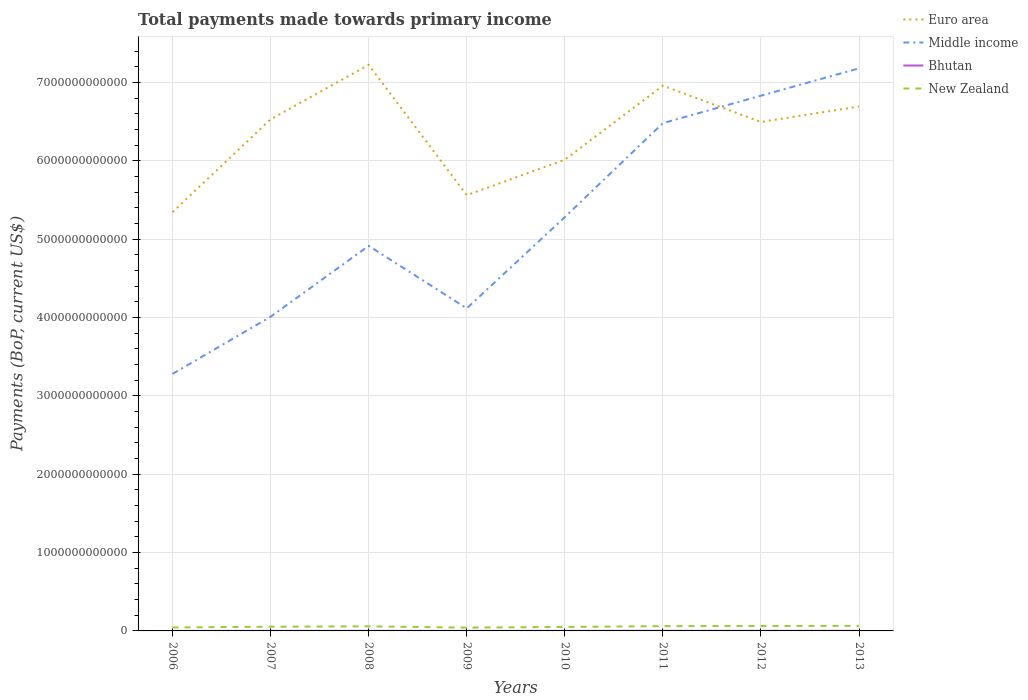Across all years, what is the maximum total payments made towards primary income in Bhutan?
Make the answer very short. 5.25e+08. In which year was the total payments made towards primary income in Bhutan maximum?
Offer a very short reply. 2006. What is the total total payments made towards primary income in Euro area in the graph?
Your answer should be very brief. -4.54e+11. What is the difference between the highest and the second highest total payments made towards primary income in Middle income?
Offer a terse response. 3.90e+12. Is the total payments made towards primary income in Euro area strictly greater than the total payments made towards primary income in New Zealand over the years?
Your response must be concise. No. How many lines are there?
Your answer should be very brief. 4. What is the difference between two consecutive major ticks on the Y-axis?
Give a very brief answer. 1.00e+12. Are the values on the major ticks of Y-axis written in scientific E-notation?
Offer a very short reply. No. Does the graph contain any zero values?
Provide a succinct answer. No. How are the legend labels stacked?
Keep it short and to the point. Vertical. What is the title of the graph?
Your answer should be compact. Total payments made towards primary income. Does "Turks and Caicos Islands" appear as one of the legend labels in the graph?
Ensure brevity in your answer.  No. What is the label or title of the X-axis?
Your response must be concise. Years. What is the label or title of the Y-axis?
Offer a terse response. Payments (BoP, current US$). What is the Payments (BoP, current US$) in Euro area in 2006?
Your answer should be very brief. 5.35e+12. What is the Payments (BoP, current US$) in Middle income in 2006?
Your response must be concise. 3.28e+12. What is the Payments (BoP, current US$) in Bhutan in 2006?
Give a very brief answer. 5.25e+08. What is the Payments (BoP, current US$) of New Zealand in 2006?
Provide a short and direct response. 4.44e+1. What is the Payments (BoP, current US$) in Euro area in 2007?
Make the answer very short. 6.53e+12. What is the Payments (BoP, current US$) in Middle income in 2007?
Offer a terse response. 4.01e+12. What is the Payments (BoP, current US$) in Bhutan in 2007?
Your answer should be very brief. 6.13e+08. What is the Payments (BoP, current US$) of New Zealand in 2007?
Offer a terse response. 5.38e+1. What is the Payments (BoP, current US$) in Euro area in 2008?
Provide a succinct answer. 7.23e+12. What is the Payments (BoP, current US$) of Middle income in 2008?
Offer a very short reply. 4.92e+12. What is the Payments (BoP, current US$) in Bhutan in 2008?
Provide a succinct answer. 8.35e+08. What is the Payments (BoP, current US$) of New Zealand in 2008?
Offer a very short reply. 5.83e+1. What is the Payments (BoP, current US$) in Euro area in 2009?
Keep it short and to the point. 5.56e+12. What is the Payments (BoP, current US$) in Middle income in 2009?
Offer a very short reply. 4.12e+12. What is the Payments (BoP, current US$) in Bhutan in 2009?
Ensure brevity in your answer.  7.35e+08. What is the Payments (BoP, current US$) of New Zealand in 2009?
Give a very brief answer. 4.20e+1. What is the Payments (BoP, current US$) in Euro area in 2010?
Ensure brevity in your answer.  6.02e+12. What is the Payments (BoP, current US$) of Middle income in 2010?
Give a very brief answer. 5.28e+12. What is the Payments (BoP, current US$) in Bhutan in 2010?
Your answer should be compact. 1.02e+09. What is the Payments (BoP, current US$) of New Zealand in 2010?
Ensure brevity in your answer.  5.09e+1. What is the Payments (BoP, current US$) of Euro area in 2011?
Your answer should be very brief. 6.96e+12. What is the Payments (BoP, current US$) in Middle income in 2011?
Your response must be concise. 6.48e+12. What is the Payments (BoP, current US$) of Bhutan in 2011?
Your response must be concise. 1.43e+09. What is the Payments (BoP, current US$) in New Zealand in 2011?
Provide a succinct answer. 6.09e+1. What is the Payments (BoP, current US$) of Euro area in 2012?
Your answer should be very brief. 6.50e+12. What is the Payments (BoP, current US$) of Middle income in 2012?
Give a very brief answer. 6.83e+12. What is the Payments (BoP, current US$) of Bhutan in 2012?
Your answer should be compact. 1.34e+09. What is the Payments (BoP, current US$) of New Zealand in 2012?
Offer a very short reply. 6.28e+1. What is the Payments (BoP, current US$) in Euro area in 2013?
Make the answer very short. 6.69e+12. What is the Payments (BoP, current US$) of Middle income in 2013?
Make the answer very short. 7.18e+12. What is the Payments (BoP, current US$) in Bhutan in 2013?
Make the answer very short. 1.32e+09. What is the Payments (BoP, current US$) of New Zealand in 2013?
Provide a short and direct response. 6.45e+1. Across all years, what is the maximum Payments (BoP, current US$) in Euro area?
Offer a very short reply. 7.23e+12. Across all years, what is the maximum Payments (BoP, current US$) of Middle income?
Offer a terse response. 7.18e+12. Across all years, what is the maximum Payments (BoP, current US$) in Bhutan?
Offer a terse response. 1.43e+09. Across all years, what is the maximum Payments (BoP, current US$) of New Zealand?
Your response must be concise. 6.45e+1. Across all years, what is the minimum Payments (BoP, current US$) in Euro area?
Provide a short and direct response. 5.35e+12. Across all years, what is the minimum Payments (BoP, current US$) of Middle income?
Give a very brief answer. 3.28e+12. Across all years, what is the minimum Payments (BoP, current US$) of Bhutan?
Your response must be concise. 5.25e+08. Across all years, what is the minimum Payments (BoP, current US$) in New Zealand?
Your response must be concise. 4.20e+1. What is the total Payments (BoP, current US$) of Euro area in the graph?
Provide a short and direct response. 5.08e+13. What is the total Payments (BoP, current US$) in Middle income in the graph?
Your answer should be compact. 4.21e+13. What is the total Payments (BoP, current US$) in Bhutan in the graph?
Your response must be concise. 7.82e+09. What is the total Payments (BoP, current US$) of New Zealand in the graph?
Your answer should be compact. 4.38e+11. What is the difference between the Payments (BoP, current US$) of Euro area in 2006 and that in 2007?
Make the answer very short. -1.19e+12. What is the difference between the Payments (BoP, current US$) in Middle income in 2006 and that in 2007?
Give a very brief answer. -7.29e+11. What is the difference between the Payments (BoP, current US$) of Bhutan in 2006 and that in 2007?
Provide a succinct answer. -8.84e+07. What is the difference between the Payments (BoP, current US$) of New Zealand in 2006 and that in 2007?
Your answer should be compact. -9.38e+09. What is the difference between the Payments (BoP, current US$) in Euro area in 2006 and that in 2008?
Provide a succinct answer. -1.88e+12. What is the difference between the Payments (BoP, current US$) in Middle income in 2006 and that in 2008?
Offer a terse response. -1.63e+12. What is the difference between the Payments (BoP, current US$) of Bhutan in 2006 and that in 2008?
Ensure brevity in your answer.  -3.11e+08. What is the difference between the Payments (BoP, current US$) of New Zealand in 2006 and that in 2008?
Provide a succinct answer. -1.39e+1. What is the difference between the Payments (BoP, current US$) in Euro area in 2006 and that in 2009?
Give a very brief answer. -2.16e+11. What is the difference between the Payments (BoP, current US$) of Middle income in 2006 and that in 2009?
Your answer should be compact. -8.36e+11. What is the difference between the Payments (BoP, current US$) of Bhutan in 2006 and that in 2009?
Your answer should be very brief. -2.10e+08. What is the difference between the Payments (BoP, current US$) of New Zealand in 2006 and that in 2009?
Provide a succinct answer. 2.41e+09. What is the difference between the Payments (BoP, current US$) in Euro area in 2006 and that in 2010?
Give a very brief answer. -6.69e+11. What is the difference between the Payments (BoP, current US$) in Middle income in 2006 and that in 2010?
Provide a succinct answer. -2.00e+12. What is the difference between the Payments (BoP, current US$) of Bhutan in 2006 and that in 2010?
Your answer should be compact. -4.99e+08. What is the difference between the Payments (BoP, current US$) of New Zealand in 2006 and that in 2010?
Offer a very short reply. -6.54e+09. What is the difference between the Payments (BoP, current US$) in Euro area in 2006 and that in 2011?
Make the answer very short. -1.61e+12. What is the difference between the Payments (BoP, current US$) of Middle income in 2006 and that in 2011?
Give a very brief answer. -3.20e+12. What is the difference between the Payments (BoP, current US$) of Bhutan in 2006 and that in 2011?
Ensure brevity in your answer.  -9.01e+08. What is the difference between the Payments (BoP, current US$) of New Zealand in 2006 and that in 2011?
Offer a very short reply. -1.65e+1. What is the difference between the Payments (BoP, current US$) of Euro area in 2006 and that in 2012?
Keep it short and to the point. -1.15e+12. What is the difference between the Payments (BoP, current US$) of Middle income in 2006 and that in 2012?
Give a very brief answer. -3.55e+12. What is the difference between the Payments (BoP, current US$) in Bhutan in 2006 and that in 2012?
Provide a succinct answer. -8.19e+08. What is the difference between the Payments (BoP, current US$) in New Zealand in 2006 and that in 2012?
Offer a very short reply. -1.84e+1. What is the difference between the Payments (BoP, current US$) in Euro area in 2006 and that in 2013?
Ensure brevity in your answer.  -1.35e+12. What is the difference between the Payments (BoP, current US$) in Middle income in 2006 and that in 2013?
Your answer should be compact. -3.90e+12. What is the difference between the Payments (BoP, current US$) in Bhutan in 2006 and that in 2013?
Your answer should be compact. -7.91e+08. What is the difference between the Payments (BoP, current US$) in New Zealand in 2006 and that in 2013?
Keep it short and to the point. -2.01e+1. What is the difference between the Payments (BoP, current US$) of Euro area in 2007 and that in 2008?
Your answer should be compact. -6.94e+11. What is the difference between the Payments (BoP, current US$) in Middle income in 2007 and that in 2008?
Offer a terse response. -9.05e+11. What is the difference between the Payments (BoP, current US$) of Bhutan in 2007 and that in 2008?
Your answer should be compact. -2.22e+08. What is the difference between the Payments (BoP, current US$) of New Zealand in 2007 and that in 2008?
Provide a succinct answer. -4.56e+09. What is the difference between the Payments (BoP, current US$) of Euro area in 2007 and that in 2009?
Give a very brief answer. 9.69e+11. What is the difference between the Payments (BoP, current US$) of Middle income in 2007 and that in 2009?
Offer a very short reply. -1.07e+11. What is the difference between the Payments (BoP, current US$) in Bhutan in 2007 and that in 2009?
Ensure brevity in your answer.  -1.22e+08. What is the difference between the Payments (BoP, current US$) in New Zealand in 2007 and that in 2009?
Your answer should be compact. 1.18e+1. What is the difference between the Payments (BoP, current US$) in Euro area in 2007 and that in 2010?
Offer a terse response. 5.16e+11. What is the difference between the Payments (BoP, current US$) in Middle income in 2007 and that in 2010?
Your response must be concise. -1.27e+12. What is the difference between the Payments (BoP, current US$) in Bhutan in 2007 and that in 2010?
Your response must be concise. -4.11e+08. What is the difference between the Payments (BoP, current US$) in New Zealand in 2007 and that in 2010?
Provide a succinct answer. 2.84e+09. What is the difference between the Payments (BoP, current US$) in Euro area in 2007 and that in 2011?
Make the answer very short. -4.29e+11. What is the difference between the Payments (BoP, current US$) in Middle income in 2007 and that in 2011?
Keep it short and to the point. -2.47e+12. What is the difference between the Payments (BoP, current US$) of Bhutan in 2007 and that in 2011?
Your response must be concise. -8.12e+08. What is the difference between the Payments (BoP, current US$) of New Zealand in 2007 and that in 2011?
Give a very brief answer. -7.08e+09. What is the difference between the Payments (BoP, current US$) in Euro area in 2007 and that in 2012?
Keep it short and to the point. 3.43e+1. What is the difference between the Payments (BoP, current US$) of Middle income in 2007 and that in 2012?
Ensure brevity in your answer.  -2.82e+12. What is the difference between the Payments (BoP, current US$) of Bhutan in 2007 and that in 2012?
Your answer should be compact. -7.30e+08. What is the difference between the Payments (BoP, current US$) in New Zealand in 2007 and that in 2012?
Offer a very short reply. -9.00e+09. What is the difference between the Payments (BoP, current US$) in Euro area in 2007 and that in 2013?
Make the answer very short. -1.63e+11. What is the difference between the Payments (BoP, current US$) of Middle income in 2007 and that in 2013?
Your response must be concise. -3.17e+12. What is the difference between the Payments (BoP, current US$) in Bhutan in 2007 and that in 2013?
Ensure brevity in your answer.  -7.03e+08. What is the difference between the Payments (BoP, current US$) in New Zealand in 2007 and that in 2013?
Your response must be concise. -1.08e+1. What is the difference between the Payments (BoP, current US$) in Euro area in 2008 and that in 2009?
Give a very brief answer. 1.66e+12. What is the difference between the Payments (BoP, current US$) in Middle income in 2008 and that in 2009?
Provide a succinct answer. 7.98e+11. What is the difference between the Payments (BoP, current US$) in Bhutan in 2008 and that in 2009?
Keep it short and to the point. 1.00e+08. What is the difference between the Payments (BoP, current US$) in New Zealand in 2008 and that in 2009?
Provide a succinct answer. 1.64e+1. What is the difference between the Payments (BoP, current US$) of Euro area in 2008 and that in 2010?
Ensure brevity in your answer.  1.21e+12. What is the difference between the Payments (BoP, current US$) in Middle income in 2008 and that in 2010?
Offer a terse response. -3.67e+11. What is the difference between the Payments (BoP, current US$) in Bhutan in 2008 and that in 2010?
Offer a very short reply. -1.88e+08. What is the difference between the Payments (BoP, current US$) in New Zealand in 2008 and that in 2010?
Make the answer very short. 7.40e+09. What is the difference between the Payments (BoP, current US$) of Euro area in 2008 and that in 2011?
Provide a succinct answer. 2.65e+11. What is the difference between the Payments (BoP, current US$) in Middle income in 2008 and that in 2011?
Give a very brief answer. -1.57e+12. What is the difference between the Payments (BoP, current US$) of Bhutan in 2008 and that in 2011?
Provide a short and direct response. -5.90e+08. What is the difference between the Payments (BoP, current US$) in New Zealand in 2008 and that in 2011?
Give a very brief answer. -2.52e+09. What is the difference between the Payments (BoP, current US$) in Euro area in 2008 and that in 2012?
Keep it short and to the point. 7.29e+11. What is the difference between the Payments (BoP, current US$) in Middle income in 2008 and that in 2012?
Give a very brief answer. -1.92e+12. What is the difference between the Payments (BoP, current US$) in Bhutan in 2008 and that in 2012?
Give a very brief answer. -5.08e+08. What is the difference between the Payments (BoP, current US$) of New Zealand in 2008 and that in 2012?
Provide a short and direct response. -4.45e+09. What is the difference between the Payments (BoP, current US$) of Euro area in 2008 and that in 2013?
Your response must be concise. 5.32e+11. What is the difference between the Payments (BoP, current US$) in Middle income in 2008 and that in 2013?
Ensure brevity in your answer.  -2.27e+12. What is the difference between the Payments (BoP, current US$) in Bhutan in 2008 and that in 2013?
Your response must be concise. -4.81e+08. What is the difference between the Payments (BoP, current US$) in New Zealand in 2008 and that in 2013?
Ensure brevity in your answer.  -6.20e+09. What is the difference between the Payments (BoP, current US$) of Euro area in 2009 and that in 2010?
Ensure brevity in your answer.  -4.54e+11. What is the difference between the Payments (BoP, current US$) in Middle income in 2009 and that in 2010?
Your answer should be compact. -1.16e+12. What is the difference between the Payments (BoP, current US$) of Bhutan in 2009 and that in 2010?
Your answer should be compact. -2.89e+08. What is the difference between the Payments (BoP, current US$) in New Zealand in 2009 and that in 2010?
Offer a very short reply. -8.95e+09. What is the difference between the Payments (BoP, current US$) in Euro area in 2009 and that in 2011?
Your response must be concise. -1.40e+12. What is the difference between the Payments (BoP, current US$) of Middle income in 2009 and that in 2011?
Provide a succinct answer. -2.36e+12. What is the difference between the Payments (BoP, current US$) of Bhutan in 2009 and that in 2011?
Make the answer very short. -6.90e+08. What is the difference between the Payments (BoP, current US$) in New Zealand in 2009 and that in 2011?
Offer a very short reply. -1.89e+1. What is the difference between the Payments (BoP, current US$) of Euro area in 2009 and that in 2012?
Provide a succinct answer. -9.35e+11. What is the difference between the Payments (BoP, current US$) in Middle income in 2009 and that in 2012?
Provide a short and direct response. -2.72e+12. What is the difference between the Payments (BoP, current US$) of Bhutan in 2009 and that in 2012?
Provide a short and direct response. -6.08e+08. What is the difference between the Payments (BoP, current US$) of New Zealand in 2009 and that in 2012?
Your answer should be compact. -2.08e+1. What is the difference between the Payments (BoP, current US$) of Euro area in 2009 and that in 2013?
Your response must be concise. -1.13e+12. What is the difference between the Payments (BoP, current US$) in Middle income in 2009 and that in 2013?
Your answer should be compact. -3.06e+12. What is the difference between the Payments (BoP, current US$) of Bhutan in 2009 and that in 2013?
Give a very brief answer. -5.81e+08. What is the difference between the Payments (BoP, current US$) of New Zealand in 2009 and that in 2013?
Your response must be concise. -2.25e+1. What is the difference between the Payments (BoP, current US$) in Euro area in 2010 and that in 2011?
Provide a short and direct response. -9.45e+11. What is the difference between the Payments (BoP, current US$) of Middle income in 2010 and that in 2011?
Your answer should be very brief. -1.20e+12. What is the difference between the Payments (BoP, current US$) in Bhutan in 2010 and that in 2011?
Offer a terse response. -4.02e+08. What is the difference between the Payments (BoP, current US$) of New Zealand in 2010 and that in 2011?
Your answer should be compact. -9.92e+09. What is the difference between the Payments (BoP, current US$) in Euro area in 2010 and that in 2012?
Make the answer very short. -4.82e+11. What is the difference between the Payments (BoP, current US$) in Middle income in 2010 and that in 2012?
Provide a succinct answer. -1.55e+12. What is the difference between the Payments (BoP, current US$) of Bhutan in 2010 and that in 2012?
Ensure brevity in your answer.  -3.20e+08. What is the difference between the Payments (BoP, current US$) in New Zealand in 2010 and that in 2012?
Offer a very short reply. -1.18e+1. What is the difference between the Payments (BoP, current US$) of Euro area in 2010 and that in 2013?
Offer a terse response. -6.79e+11. What is the difference between the Payments (BoP, current US$) in Middle income in 2010 and that in 2013?
Keep it short and to the point. -1.90e+12. What is the difference between the Payments (BoP, current US$) of Bhutan in 2010 and that in 2013?
Offer a very short reply. -2.92e+08. What is the difference between the Payments (BoP, current US$) in New Zealand in 2010 and that in 2013?
Provide a short and direct response. -1.36e+1. What is the difference between the Payments (BoP, current US$) in Euro area in 2011 and that in 2012?
Provide a succinct answer. 4.63e+11. What is the difference between the Payments (BoP, current US$) in Middle income in 2011 and that in 2012?
Provide a succinct answer. -3.51e+11. What is the difference between the Payments (BoP, current US$) in Bhutan in 2011 and that in 2012?
Ensure brevity in your answer.  8.20e+07. What is the difference between the Payments (BoP, current US$) in New Zealand in 2011 and that in 2012?
Provide a succinct answer. -1.92e+09. What is the difference between the Payments (BoP, current US$) in Euro area in 2011 and that in 2013?
Your response must be concise. 2.66e+11. What is the difference between the Payments (BoP, current US$) of Middle income in 2011 and that in 2013?
Your answer should be very brief. -7.00e+11. What is the difference between the Payments (BoP, current US$) in Bhutan in 2011 and that in 2013?
Give a very brief answer. 1.10e+08. What is the difference between the Payments (BoP, current US$) of New Zealand in 2011 and that in 2013?
Ensure brevity in your answer.  -3.68e+09. What is the difference between the Payments (BoP, current US$) of Euro area in 2012 and that in 2013?
Offer a very short reply. -1.97e+11. What is the difference between the Payments (BoP, current US$) in Middle income in 2012 and that in 2013?
Give a very brief answer. -3.49e+11. What is the difference between the Payments (BoP, current US$) in Bhutan in 2012 and that in 2013?
Provide a succinct answer. 2.76e+07. What is the difference between the Payments (BoP, current US$) of New Zealand in 2012 and that in 2013?
Make the answer very short. -1.75e+09. What is the difference between the Payments (BoP, current US$) in Euro area in 2006 and the Payments (BoP, current US$) in Middle income in 2007?
Offer a very short reply. 1.34e+12. What is the difference between the Payments (BoP, current US$) of Euro area in 2006 and the Payments (BoP, current US$) of Bhutan in 2007?
Your response must be concise. 5.35e+12. What is the difference between the Payments (BoP, current US$) of Euro area in 2006 and the Payments (BoP, current US$) of New Zealand in 2007?
Offer a very short reply. 5.29e+12. What is the difference between the Payments (BoP, current US$) of Middle income in 2006 and the Payments (BoP, current US$) of Bhutan in 2007?
Your answer should be very brief. 3.28e+12. What is the difference between the Payments (BoP, current US$) in Middle income in 2006 and the Payments (BoP, current US$) in New Zealand in 2007?
Your response must be concise. 3.23e+12. What is the difference between the Payments (BoP, current US$) in Bhutan in 2006 and the Payments (BoP, current US$) in New Zealand in 2007?
Ensure brevity in your answer.  -5.33e+1. What is the difference between the Payments (BoP, current US$) in Euro area in 2006 and the Payments (BoP, current US$) in Middle income in 2008?
Ensure brevity in your answer.  4.31e+11. What is the difference between the Payments (BoP, current US$) in Euro area in 2006 and the Payments (BoP, current US$) in Bhutan in 2008?
Your answer should be very brief. 5.35e+12. What is the difference between the Payments (BoP, current US$) in Euro area in 2006 and the Payments (BoP, current US$) in New Zealand in 2008?
Your answer should be very brief. 5.29e+12. What is the difference between the Payments (BoP, current US$) of Middle income in 2006 and the Payments (BoP, current US$) of Bhutan in 2008?
Offer a terse response. 3.28e+12. What is the difference between the Payments (BoP, current US$) of Middle income in 2006 and the Payments (BoP, current US$) of New Zealand in 2008?
Offer a terse response. 3.22e+12. What is the difference between the Payments (BoP, current US$) of Bhutan in 2006 and the Payments (BoP, current US$) of New Zealand in 2008?
Provide a succinct answer. -5.78e+1. What is the difference between the Payments (BoP, current US$) in Euro area in 2006 and the Payments (BoP, current US$) in Middle income in 2009?
Make the answer very short. 1.23e+12. What is the difference between the Payments (BoP, current US$) in Euro area in 2006 and the Payments (BoP, current US$) in Bhutan in 2009?
Provide a short and direct response. 5.35e+12. What is the difference between the Payments (BoP, current US$) of Euro area in 2006 and the Payments (BoP, current US$) of New Zealand in 2009?
Offer a terse response. 5.31e+12. What is the difference between the Payments (BoP, current US$) in Middle income in 2006 and the Payments (BoP, current US$) in Bhutan in 2009?
Offer a very short reply. 3.28e+12. What is the difference between the Payments (BoP, current US$) in Middle income in 2006 and the Payments (BoP, current US$) in New Zealand in 2009?
Ensure brevity in your answer.  3.24e+12. What is the difference between the Payments (BoP, current US$) in Bhutan in 2006 and the Payments (BoP, current US$) in New Zealand in 2009?
Offer a terse response. -4.15e+1. What is the difference between the Payments (BoP, current US$) in Euro area in 2006 and the Payments (BoP, current US$) in Middle income in 2010?
Provide a short and direct response. 6.41e+1. What is the difference between the Payments (BoP, current US$) of Euro area in 2006 and the Payments (BoP, current US$) of Bhutan in 2010?
Provide a succinct answer. 5.35e+12. What is the difference between the Payments (BoP, current US$) in Euro area in 2006 and the Payments (BoP, current US$) in New Zealand in 2010?
Your answer should be compact. 5.30e+12. What is the difference between the Payments (BoP, current US$) in Middle income in 2006 and the Payments (BoP, current US$) in Bhutan in 2010?
Your answer should be very brief. 3.28e+12. What is the difference between the Payments (BoP, current US$) in Middle income in 2006 and the Payments (BoP, current US$) in New Zealand in 2010?
Offer a terse response. 3.23e+12. What is the difference between the Payments (BoP, current US$) of Bhutan in 2006 and the Payments (BoP, current US$) of New Zealand in 2010?
Offer a terse response. -5.04e+1. What is the difference between the Payments (BoP, current US$) in Euro area in 2006 and the Payments (BoP, current US$) in Middle income in 2011?
Your answer should be very brief. -1.14e+12. What is the difference between the Payments (BoP, current US$) in Euro area in 2006 and the Payments (BoP, current US$) in Bhutan in 2011?
Your answer should be compact. 5.35e+12. What is the difference between the Payments (BoP, current US$) of Euro area in 2006 and the Payments (BoP, current US$) of New Zealand in 2011?
Make the answer very short. 5.29e+12. What is the difference between the Payments (BoP, current US$) in Middle income in 2006 and the Payments (BoP, current US$) in Bhutan in 2011?
Keep it short and to the point. 3.28e+12. What is the difference between the Payments (BoP, current US$) in Middle income in 2006 and the Payments (BoP, current US$) in New Zealand in 2011?
Make the answer very short. 3.22e+12. What is the difference between the Payments (BoP, current US$) in Bhutan in 2006 and the Payments (BoP, current US$) in New Zealand in 2011?
Your answer should be compact. -6.03e+1. What is the difference between the Payments (BoP, current US$) of Euro area in 2006 and the Payments (BoP, current US$) of Middle income in 2012?
Provide a succinct answer. -1.49e+12. What is the difference between the Payments (BoP, current US$) in Euro area in 2006 and the Payments (BoP, current US$) in Bhutan in 2012?
Your answer should be compact. 5.35e+12. What is the difference between the Payments (BoP, current US$) of Euro area in 2006 and the Payments (BoP, current US$) of New Zealand in 2012?
Keep it short and to the point. 5.28e+12. What is the difference between the Payments (BoP, current US$) in Middle income in 2006 and the Payments (BoP, current US$) in Bhutan in 2012?
Your response must be concise. 3.28e+12. What is the difference between the Payments (BoP, current US$) in Middle income in 2006 and the Payments (BoP, current US$) in New Zealand in 2012?
Ensure brevity in your answer.  3.22e+12. What is the difference between the Payments (BoP, current US$) of Bhutan in 2006 and the Payments (BoP, current US$) of New Zealand in 2012?
Your answer should be very brief. -6.23e+1. What is the difference between the Payments (BoP, current US$) in Euro area in 2006 and the Payments (BoP, current US$) in Middle income in 2013?
Provide a succinct answer. -1.84e+12. What is the difference between the Payments (BoP, current US$) in Euro area in 2006 and the Payments (BoP, current US$) in Bhutan in 2013?
Keep it short and to the point. 5.35e+12. What is the difference between the Payments (BoP, current US$) of Euro area in 2006 and the Payments (BoP, current US$) of New Zealand in 2013?
Your answer should be compact. 5.28e+12. What is the difference between the Payments (BoP, current US$) in Middle income in 2006 and the Payments (BoP, current US$) in Bhutan in 2013?
Make the answer very short. 3.28e+12. What is the difference between the Payments (BoP, current US$) in Middle income in 2006 and the Payments (BoP, current US$) in New Zealand in 2013?
Offer a terse response. 3.22e+12. What is the difference between the Payments (BoP, current US$) of Bhutan in 2006 and the Payments (BoP, current US$) of New Zealand in 2013?
Provide a succinct answer. -6.40e+1. What is the difference between the Payments (BoP, current US$) of Euro area in 2007 and the Payments (BoP, current US$) of Middle income in 2008?
Your answer should be compact. 1.62e+12. What is the difference between the Payments (BoP, current US$) of Euro area in 2007 and the Payments (BoP, current US$) of Bhutan in 2008?
Provide a succinct answer. 6.53e+12. What is the difference between the Payments (BoP, current US$) in Euro area in 2007 and the Payments (BoP, current US$) in New Zealand in 2008?
Offer a very short reply. 6.47e+12. What is the difference between the Payments (BoP, current US$) of Middle income in 2007 and the Payments (BoP, current US$) of Bhutan in 2008?
Offer a terse response. 4.01e+12. What is the difference between the Payments (BoP, current US$) of Middle income in 2007 and the Payments (BoP, current US$) of New Zealand in 2008?
Your response must be concise. 3.95e+12. What is the difference between the Payments (BoP, current US$) in Bhutan in 2007 and the Payments (BoP, current US$) in New Zealand in 2008?
Offer a terse response. -5.77e+1. What is the difference between the Payments (BoP, current US$) in Euro area in 2007 and the Payments (BoP, current US$) in Middle income in 2009?
Keep it short and to the point. 2.41e+12. What is the difference between the Payments (BoP, current US$) in Euro area in 2007 and the Payments (BoP, current US$) in Bhutan in 2009?
Give a very brief answer. 6.53e+12. What is the difference between the Payments (BoP, current US$) of Euro area in 2007 and the Payments (BoP, current US$) of New Zealand in 2009?
Offer a very short reply. 6.49e+12. What is the difference between the Payments (BoP, current US$) in Middle income in 2007 and the Payments (BoP, current US$) in Bhutan in 2009?
Offer a terse response. 4.01e+12. What is the difference between the Payments (BoP, current US$) of Middle income in 2007 and the Payments (BoP, current US$) of New Zealand in 2009?
Your answer should be very brief. 3.97e+12. What is the difference between the Payments (BoP, current US$) of Bhutan in 2007 and the Payments (BoP, current US$) of New Zealand in 2009?
Your answer should be compact. -4.14e+1. What is the difference between the Payments (BoP, current US$) in Euro area in 2007 and the Payments (BoP, current US$) in Middle income in 2010?
Keep it short and to the point. 1.25e+12. What is the difference between the Payments (BoP, current US$) of Euro area in 2007 and the Payments (BoP, current US$) of Bhutan in 2010?
Give a very brief answer. 6.53e+12. What is the difference between the Payments (BoP, current US$) in Euro area in 2007 and the Payments (BoP, current US$) in New Zealand in 2010?
Ensure brevity in your answer.  6.48e+12. What is the difference between the Payments (BoP, current US$) in Middle income in 2007 and the Payments (BoP, current US$) in Bhutan in 2010?
Provide a short and direct response. 4.01e+12. What is the difference between the Payments (BoP, current US$) in Middle income in 2007 and the Payments (BoP, current US$) in New Zealand in 2010?
Ensure brevity in your answer.  3.96e+12. What is the difference between the Payments (BoP, current US$) in Bhutan in 2007 and the Payments (BoP, current US$) in New Zealand in 2010?
Your answer should be very brief. -5.03e+1. What is the difference between the Payments (BoP, current US$) in Euro area in 2007 and the Payments (BoP, current US$) in Middle income in 2011?
Your answer should be compact. 4.93e+1. What is the difference between the Payments (BoP, current US$) of Euro area in 2007 and the Payments (BoP, current US$) of Bhutan in 2011?
Your answer should be compact. 6.53e+12. What is the difference between the Payments (BoP, current US$) of Euro area in 2007 and the Payments (BoP, current US$) of New Zealand in 2011?
Provide a short and direct response. 6.47e+12. What is the difference between the Payments (BoP, current US$) in Middle income in 2007 and the Payments (BoP, current US$) in Bhutan in 2011?
Give a very brief answer. 4.01e+12. What is the difference between the Payments (BoP, current US$) in Middle income in 2007 and the Payments (BoP, current US$) in New Zealand in 2011?
Give a very brief answer. 3.95e+12. What is the difference between the Payments (BoP, current US$) of Bhutan in 2007 and the Payments (BoP, current US$) of New Zealand in 2011?
Give a very brief answer. -6.03e+1. What is the difference between the Payments (BoP, current US$) of Euro area in 2007 and the Payments (BoP, current US$) of Middle income in 2012?
Your response must be concise. -3.01e+11. What is the difference between the Payments (BoP, current US$) in Euro area in 2007 and the Payments (BoP, current US$) in Bhutan in 2012?
Provide a short and direct response. 6.53e+12. What is the difference between the Payments (BoP, current US$) of Euro area in 2007 and the Payments (BoP, current US$) of New Zealand in 2012?
Provide a short and direct response. 6.47e+12. What is the difference between the Payments (BoP, current US$) in Middle income in 2007 and the Payments (BoP, current US$) in Bhutan in 2012?
Provide a succinct answer. 4.01e+12. What is the difference between the Payments (BoP, current US$) in Middle income in 2007 and the Payments (BoP, current US$) in New Zealand in 2012?
Offer a terse response. 3.95e+12. What is the difference between the Payments (BoP, current US$) of Bhutan in 2007 and the Payments (BoP, current US$) of New Zealand in 2012?
Give a very brief answer. -6.22e+1. What is the difference between the Payments (BoP, current US$) of Euro area in 2007 and the Payments (BoP, current US$) of Middle income in 2013?
Provide a succinct answer. -6.50e+11. What is the difference between the Payments (BoP, current US$) in Euro area in 2007 and the Payments (BoP, current US$) in Bhutan in 2013?
Keep it short and to the point. 6.53e+12. What is the difference between the Payments (BoP, current US$) of Euro area in 2007 and the Payments (BoP, current US$) of New Zealand in 2013?
Offer a very short reply. 6.47e+12. What is the difference between the Payments (BoP, current US$) in Middle income in 2007 and the Payments (BoP, current US$) in Bhutan in 2013?
Give a very brief answer. 4.01e+12. What is the difference between the Payments (BoP, current US$) in Middle income in 2007 and the Payments (BoP, current US$) in New Zealand in 2013?
Your response must be concise. 3.95e+12. What is the difference between the Payments (BoP, current US$) in Bhutan in 2007 and the Payments (BoP, current US$) in New Zealand in 2013?
Provide a short and direct response. -6.39e+1. What is the difference between the Payments (BoP, current US$) in Euro area in 2008 and the Payments (BoP, current US$) in Middle income in 2009?
Your answer should be compact. 3.11e+12. What is the difference between the Payments (BoP, current US$) in Euro area in 2008 and the Payments (BoP, current US$) in Bhutan in 2009?
Your answer should be very brief. 7.23e+12. What is the difference between the Payments (BoP, current US$) in Euro area in 2008 and the Payments (BoP, current US$) in New Zealand in 2009?
Your answer should be very brief. 7.18e+12. What is the difference between the Payments (BoP, current US$) of Middle income in 2008 and the Payments (BoP, current US$) of Bhutan in 2009?
Your answer should be very brief. 4.92e+12. What is the difference between the Payments (BoP, current US$) in Middle income in 2008 and the Payments (BoP, current US$) in New Zealand in 2009?
Give a very brief answer. 4.87e+12. What is the difference between the Payments (BoP, current US$) in Bhutan in 2008 and the Payments (BoP, current US$) in New Zealand in 2009?
Offer a terse response. -4.12e+1. What is the difference between the Payments (BoP, current US$) in Euro area in 2008 and the Payments (BoP, current US$) in Middle income in 2010?
Offer a terse response. 1.94e+12. What is the difference between the Payments (BoP, current US$) of Euro area in 2008 and the Payments (BoP, current US$) of Bhutan in 2010?
Give a very brief answer. 7.23e+12. What is the difference between the Payments (BoP, current US$) of Euro area in 2008 and the Payments (BoP, current US$) of New Zealand in 2010?
Provide a short and direct response. 7.18e+12. What is the difference between the Payments (BoP, current US$) in Middle income in 2008 and the Payments (BoP, current US$) in Bhutan in 2010?
Keep it short and to the point. 4.92e+12. What is the difference between the Payments (BoP, current US$) of Middle income in 2008 and the Payments (BoP, current US$) of New Zealand in 2010?
Provide a short and direct response. 4.87e+12. What is the difference between the Payments (BoP, current US$) in Bhutan in 2008 and the Payments (BoP, current US$) in New Zealand in 2010?
Provide a short and direct response. -5.01e+1. What is the difference between the Payments (BoP, current US$) in Euro area in 2008 and the Payments (BoP, current US$) in Middle income in 2011?
Provide a succinct answer. 7.44e+11. What is the difference between the Payments (BoP, current US$) of Euro area in 2008 and the Payments (BoP, current US$) of Bhutan in 2011?
Your answer should be compact. 7.23e+12. What is the difference between the Payments (BoP, current US$) in Euro area in 2008 and the Payments (BoP, current US$) in New Zealand in 2011?
Give a very brief answer. 7.17e+12. What is the difference between the Payments (BoP, current US$) of Middle income in 2008 and the Payments (BoP, current US$) of Bhutan in 2011?
Ensure brevity in your answer.  4.91e+12. What is the difference between the Payments (BoP, current US$) in Middle income in 2008 and the Payments (BoP, current US$) in New Zealand in 2011?
Give a very brief answer. 4.86e+12. What is the difference between the Payments (BoP, current US$) in Bhutan in 2008 and the Payments (BoP, current US$) in New Zealand in 2011?
Your answer should be very brief. -6.00e+1. What is the difference between the Payments (BoP, current US$) in Euro area in 2008 and the Payments (BoP, current US$) in Middle income in 2012?
Make the answer very short. 3.93e+11. What is the difference between the Payments (BoP, current US$) of Euro area in 2008 and the Payments (BoP, current US$) of Bhutan in 2012?
Provide a succinct answer. 7.23e+12. What is the difference between the Payments (BoP, current US$) of Euro area in 2008 and the Payments (BoP, current US$) of New Zealand in 2012?
Keep it short and to the point. 7.16e+12. What is the difference between the Payments (BoP, current US$) in Middle income in 2008 and the Payments (BoP, current US$) in Bhutan in 2012?
Ensure brevity in your answer.  4.91e+12. What is the difference between the Payments (BoP, current US$) in Middle income in 2008 and the Payments (BoP, current US$) in New Zealand in 2012?
Give a very brief answer. 4.85e+12. What is the difference between the Payments (BoP, current US$) in Bhutan in 2008 and the Payments (BoP, current US$) in New Zealand in 2012?
Provide a short and direct response. -6.20e+1. What is the difference between the Payments (BoP, current US$) in Euro area in 2008 and the Payments (BoP, current US$) in Middle income in 2013?
Make the answer very short. 4.41e+1. What is the difference between the Payments (BoP, current US$) of Euro area in 2008 and the Payments (BoP, current US$) of Bhutan in 2013?
Offer a terse response. 7.23e+12. What is the difference between the Payments (BoP, current US$) in Euro area in 2008 and the Payments (BoP, current US$) in New Zealand in 2013?
Keep it short and to the point. 7.16e+12. What is the difference between the Payments (BoP, current US$) in Middle income in 2008 and the Payments (BoP, current US$) in Bhutan in 2013?
Your answer should be very brief. 4.91e+12. What is the difference between the Payments (BoP, current US$) in Middle income in 2008 and the Payments (BoP, current US$) in New Zealand in 2013?
Your response must be concise. 4.85e+12. What is the difference between the Payments (BoP, current US$) in Bhutan in 2008 and the Payments (BoP, current US$) in New Zealand in 2013?
Your answer should be very brief. -6.37e+1. What is the difference between the Payments (BoP, current US$) in Euro area in 2009 and the Payments (BoP, current US$) in Middle income in 2010?
Ensure brevity in your answer.  2.80e+11. What is the difference between the Payments (BoP, current US$) in Euro area in 2009 and the Payments (BoP, current US$) in Bhutan in 2010?
Keep it short and to the point. 5.56e+12. What is the difference between the Payments (BoP, current US$) in Euro area in 2009 and the Payments (BoP, current US$) in New Zealand in 2010?
Offer a very short reply. 5.51e+12. What is the difference between the Payments (BoP, current US$) in Middle income in 2009 and the Payments (BoP, current US$) in Bhutan in 2010?
Offer a terse response. 4.12e+12. What is the difference between the Payments (BoP, current US$) of Middle income in 2009 and the Payments (BoP, current US$) of New Zealand in 2010?
Your answer should be compact. 4.07e+12. What is the difference between the Payments (BoP, current US$) in Bhutan in 2009 and the Payments (BoP, current US$) in New Zealand in 2010?
Ensure brevity in your answer.  -5.02e+1. What is the difference between the Payments (BoP, current US$) of Euro area in 2009 and the Payments (BoP, current US$) of Middle income in 2011?
Your answer should be very brief. -9.20e+11. What is the difference between the Payments (BoP, current US$) in Euro area in 2009 and the Payments (BoP, current US$) in Bhutan in 2011?
Give a very brief answer. 5.56e+12. What is the difference between the Payments (BoP, current US$) in Euro area in 2009 and the Payments (BoP, current US$) in New Zealand in 2011?
Offer a very short reply. 5.50e+12. What is the difference between the Payments (BoP, current US$) of Middle income in 2009 and the Payments (BoP, current US$) of Bhutan in 2011?
Offer a terse response. 4.12e+12. What is the difference between the Payments (BoP, current US$) of Middle income in 2009 and the Payments (BoP, current US$) of New Zealand in 2011?
Keep it short and to the point. 4.06e+12. What is the difference between the Payments (BoP, current US$) of Bhutan in 2009 and the Payments (BoP, current US$) of New Zealand in 2011?
Your answer should be very brief. -6.01e+1. What is the difference between the Payments (BoP, current US$) in Euro area in 2009 and the Payments (BoP, current US$) in Middle income in 2012?
Offer a terse response. -1.27e+12. What is the difference between the Payments (BoP, current US$) in Euro area in 2009 and the Payments (BoP, current US$) in Bhutan in 2012?
Ensure brevity in your answer.  5.56e+12. What is the difference between the Payments (BoP, current US$) in Euro area in 2009 and the Payments (BoP, current US$) in New Zealand in 2012?
Your answer should be very brief. 5.50e+12. What is the difference between the Payments (BoP, current US$) of Middle income in 2009 and the Payments (BoP, current US$) of Bhutan in 2012?
Give a very brief answer. 4.12e+12. What is the difference between the Payments (BoP, current US$) of Middle income in 2009 and the Payments (BoP, current US$) of New Zealand in 2012?
Offer a very short reply. 4.06e+12. What is the difference between the Payments (BoP, current US$) of Bhutan in 2009 and the Payments (BoP, current US$) of New Zealand in 2012?
Offer a very short reply. -6.21e+1. What is the difference between the Payments (BoP, current US$) in Euro area in 2009 and the Payments (BoP, current US$) in Middle income in 2013?
Provide a succinct answer. -1.62e+12. What is the difference between the Payments (BoP, current US$) in Euro area in 2009 and the Payments (BoP, current US$) in Bhutan in 2013?
Provide a succinct answer. 5.56e+12. What is the difference between the Payments (BoP, current US$) in Euro area in 2009 and the Payments (BoP, current US$) in New Zealand in 2013?
Your answer should be very brief. 5.50e+12. What is the difference between the Payments (BoP, current US$) in Middle income in 2009 and the Payments (BoP, current US$) in Bhutan in 2013?
Keep it short and to the point. 4.12e+12. What is the difference between the Payments (BoP, current US$) in Middle income in 2009 and the Payments (BoP, current US$) in New Zealand in 2013?
Give a very brief answer. 4.05e+12. What is the difference between the Payments (BoP, current US$) of Bhutan in 2009 and the Payments (BoP, current US$) of New Zealand in 2013?
Provide a short and direct response. -6.38e+1. What is the difference between the Payments (BoP, current US$) of Euro area in 2010 and the Payments (BoP, current US$) of Middle income in 2011?
Ensure brevity in your answer.  -4.67e+11. What is the difference between the Payments (BoP, current US$) of Euro area in 2010 and the Payments (BoP, current US$) of Bhutan in 2011?
Ensure brevity in your answer.  6.01e+12. What is the difference between the Payments (BoP, current US$) of Euro area in 2010 and the Payments (BoP, current US$) of New Zealand in 2011?
Your response must be concise. 5.96e+12. What is the difference between the Payments (BoP, current US$) in Middle income in 2010 and the Payments (BoP, current US$) in Bhutan in 2011?
Offer a terse response. 5.28e+12. What is the difference between the Payments (BoP, current US$) of Middle income in 2010 and the Payments (BoP, current US$) of New Zealand in 2011?
Your answer should be very brief. 5.22e+12. What is the difference between the Payments (BoP, current US$) of Bhutan in 2010 and the Payments (BoP, current US$) of New Zealand in 2011?
Provide a succinct answer. -5.98e+1. What is the difference between the Payments (BoP, current US$) of Euro area in 2010 and the Payments (BoP, current US$) of Middle income in 2012?
Ensure brevity in your answer.  -8.17e+11. What is the difference between the Payments (BoP, current US$) of Euro area in 2010 and the Payments (BoP, current US$) of Bhutan in 2012?
Offer a terse response. 6.01e+12. What is the difference between the Payments (BoP, current US$) in Euro area in 2010 and the Payments (BoP, current US$) in New Zealand in 2012?
Your answer should be compact. 5.95e+12. What is the difference between the Payments (BoP, current US$) of Middle income in 2010 and the Payments (BoP, current US$) of Bhutan in 2012?
Your answer should be compact. 5.28e+12. What is the difference between the Payments (BoP, current US$) in Middle income in 2010 and the Payments (BoP, current US$) in New Zealand in 2012?
Your answer should be very brief. 5.22e+12. What is the difference between the Payments (BoP, current US$) in Bhutan in 2010 and the Payments (BoP, current US$) in New Zealand in 2012?
Make the answer very short. -6.18e+1. What is the difference between the Payments (BoP, current US$) in Euro area in 2010 and the Payments (BoP, current US$) in Middle income in 2013?
Keep it short and to the point. -1.17e+12. What is the difference between the Payments (BoP, current US$) of Euro area in 2010 and the Payments (BoP, current US$) of Bhutan in 2013?
Keep it short and to the point. 6.01e+12. What is the difference between the Payments (BoP, current US$) of Euro area in 2010 and the Payments (BoP, current US$) of New Zealand in 2013?
Your response must be concise. 5.95e+12. What is the difference between the Payments (BoP, current US$) of Middle income in 2010 and the Payments (BoP, current US$) of Bhutan in 2013?
Your answer should be compact. 5.28e+12. What is the difference between the Payments (BoP, current US$) of Middle income in 2010 and the Payments (BoP, current US$) of New Zealand in 2013?
Keep it short and to the point. 5.22e+12. What is the difference between the Payments (BoP, current US$) in Bhutan in 2010 and the Payments (BoP, current US$) in New Zealand in 2013?
Make the answer very short. -6.35e+1. What is the difference between the Payments (BoP, current US$) of Euro area in 2011 and the Payments (BoP, current US$) of Middle income in 2012?
Your answer should be compact. 1.28e+11. What is the difference between the Payments (BoP, current US$) of Euro area in 2011 and the Payments (BoP, current US$) of Bhutan in 2012?
Offer a very short reply. 6.96e+12. What is the difference between the Payments (BoP, current US$) of Euro area in 2011 and the Payments (BoP, current US$) of New Zealand in 2012?
Give a very brief answer. 6.90e+12. What is the difference between the Payments (BoP, current US$) in Middle income in 2011 and the Payments (BoP, current US$) in Bhutan in 2012?
Provide a short and direct response. 6.48e+12. What is the difference between the Payments (BoP, current US$) in Middle income in 2011 and the Payments (BoP, current US$) in New Zealand in 2012?
Provide a succinct answer. 6.42e+12. What is the difference between the Payments (BoP, current US$) in Bhutan in 2011 and the Payments (BoP, current US$) in New Zealand in 2012?
Make the answer very short. -6.14e+1. What is the difference between the Payments (BoP, current US$) of Euro area in 2011 and the Payments (BoP, current US$) of Middle income in 2013?
Give a very brief answer. -2.21e+11. What is the difference between the Payments (BoP, current US$) of Euro area in 2011 and the Payments (BoP, current US$) of Bhutan in 2013?
Give a very brief answer. 6.96e+12. What is the difference between the Payments (BoP, current US$) of Euro area in 2011 and the Payments (BoP, current US$) of New Zealand in 2013?
Give a very brief answer. 6.90e+12. What is the difference between the Payments (BoP, current US$) of Middle income in 2011 and the Payments (BoP, current US$) of Bhutan in 2013?
Provide a succinct answer. 6.48e+12. What is the difference between the Payments (BoP, current US$) of Middle income in 2011 and the Payments (BoP, current US$) of New Zealand in 2013?
Offer a very short reply. 6.42e+12. What is the difference between the Payments (BoP, current US$) in Bhutan in 2011 and the Payments (BoP, current US$) in New Zealand in 2013?
Provide a short and direct response. -6.31e+1. What is the difference between the Payments (BoP, current US$) of Euro area in 2012 and the Payments (BoP, current US$) of Middle income in 2013?
Provide a succinct answer. -6.85e+11. What is the difference between the Payments (BoP, current US$) in Euro area in 2012 and the Payments (BoP, current US$) in Bhutan in 2013?
Your answer should be very brief. 6.50e+12. What is the difference between the Payments (BoP, current US$) in Euro area in 2012 and the Payments (BoP, current US$) in New Zealand in 2013?
Provide a short and direct response. 6.43e+12. What is the difference between the Payments (BoP, current US$) in Middle income in 2012 and the Payments (BoP, current US$) in Bhutan in 2013?
Your answer should be very brief. 6.83e+12. What is the difference between the Payments (BoP, current US$) of Middle income in 2012 and the Payments (BoP, current US$) of New Zealand in 2013?
Provide a succinct answer. 6.77e+12. What is the difference between the Payments (BoP, current US$) of Bhutan in 2012 and the Payments (BoP, current US$) of New Zealand in 2013?
Your response must be concise. -6.32e+1. What is the average Payments (BoP, current US$) of Euro area per year?
Your response must be concise. 6.35e+12. What is the average Payments (BoP, current US$) in Middle income per year?
Offer a very short reply. 5.26e+12. What is the average Payments (BoP, current US$) of Bhutan per year?
Keep it short and to the point. 9.77e+08. What is the average Payments (BoP, current US$) in New Zealand per year?
Ensure brevity in your answer.  5.47e+1. In the year 2006, what is the difference between the Payments (BoP, current US$) in Euro area and Payments (BoP, current US$) in Middle income?
Provide a succinct answer. 2.07e+12. In the year 2006, what is the difference between the Payments (BoP, current US$) in Euro area and Payments (BoP, current US$) in Bhutan?
Your answer should be very brief. 5.35e+12. In the year 2006, what is the difference between the Payments (BoP, current US$) of Euro area and Payments (BoP, current US$) of New Zealand?
Give a very brief answer. 5.30e+12. In the year 2006, what is the difference between the Payments (BoP, current US$) of Middle income and Payments (BoP, current US$) of Bhutan?
Keep it short and to the point. 3.28e+12. In the year 2006, what is the difference between the Payments (BoP, current US$) of Middle income and Payments (BoP, current US$) of New Zealand?
Your response must be concise. 3.24e+12. In the year 2006, what is the difference between the Payments (BoP, current US$) of Bhutan and Payments (BoP, current US$) of New Zealand?
Your response must be concise. -4.39e+1. In the year 2007, what is the difference between the Payments (BoP, current US$) of Euro area and Payments (BoP, current US$) of Middle income?
Your response must be concise. 2.52e+12. In the year 2007, what is the difference between the Payments (BoP, current US$) in Euro area and Payments (BoP, current US$) in Bhutan?
Make the answer very short. 6.53e+12. In the year 2007, what is the difference between the Payments (BoP, current US$) of Euro area and Payments (BoP, current US$) of New Zealand?
Make the answer very short. 6.48e+12. In the year 2007, what is the difference between the Payments (BoP, current US$) in Middle income and Payments (BoP, current US$) in Bhutan?
Keep it short and to the point. 4.01e+12. In the year 2007, what is the difference between the Payments (BoP, current US$) in Middle income and Payments (BoP, current US$) in New Zealand?
Keep it short and to the point. 3.96e+12. In the year 2007, what is the difference between the Payments (BoP, current US$) in Bhutan and Payments (BoP, current US$) in New Zealand?
Your answer should be very brief. -5.32e+1. In the year 2008, what is the difference between the Payments (BoP, current US$) of Euro area and Payments (BoP, current US$) of Middle income?
Offer a very short reply. 2.31e+12. In the year 2008, what is the difference between the Payments (BoP, current US$) in Euro area and Payments (BoP, current US$) in Bhutan?
Provide a short and direct response. 7.23e+12. In the year 2008, what is the difference between the Payments (BoP, current US$) in Euro area and Payments (BoP, current US$) in New Zealand?
Offer a terse response. 7.17e+12. In the year 2008, what is the difference between the Payments (BoP, current US$) of Middle income and Payments (BoP, current US$) of Bhutan?
Give a very brief answer. 4.92e+12. In the year 2008, what is the difference between the Payments (BoP, current US$) of Middle income and Payments (BoP, current US$) of New Zealand?
Provide a short and direct response. 4.86e+12. In the year 2008, what is the difference between the Payments (BoP, current US$) of Bhutan and Payments (BoP, current US$) of New Zealand?
Ensure brevity in your answer.  -5.75e+1. In the year 2009, what is the difference between the Payments (BoP, current US$) of Euro area and Payments (BoP, current US$) of Middle income?
Keep it short and to the point. 1.44e+12. In the year 2009, what is the difference between the Payments (BoP, current US$) of Euro area and Payments (BoP, current US$) of Bhutan?
Offer a terse response. 5.56e+12. In the year 2009, what is the difference between the Payments (BoP, current US$) of Euro area and Payments (BoP, current US$) of New Zealand?
Provide a short and direct response. 5.52e+12. In the year 2009, what is the difference between the Payments (BoP, current US$) of Middle income and Payments (BoP, current US$) of Bhutan?
Your answer should be very brief. 4.12e+12. In the year 2009, what is the difference between the Payments (BoP, current US$) in Middle income and Payments (BoP, current US$) in New Zealand?
Make the answer very short. 4.08e+12. In the year 2009, what is the difference between the Payments (BoP, current US$) of Bhutan and Payments (BoP, current US$) of New Zealand?
Ensure brevity in your answer.  -4.13e+1. In the year 2010, what is the difference between the Payments (BoP, current US$) of Euro area and Payments (BoP, current US$) of Middle income?
Give a very brief answer. 7.33e+11. In the year 2010, what is the difference between the Payments (BoP, current US$) in Euro area and Payments (BoP, current US$) in Bhutan?
Provide a short and direct response. 6.02e+12. In the year 2010, what is the difference between the Payments (BoP, current US$) of Euro area and Payments (BoP, current US$) of New Zealand?
Offer a very short reply. 5.97e+12. In the year 2010, what is the difference between the Payments (BoP, current US$) in Middle income and Payments (BoP, current US$) in Bhutan?
Offer a terse response. 5.28e+12. In the year 2010, what is the difference between the Payments (BoP, current US$) of Middle income and Payments (BoP, current US$) of New Zealand?
Keep it short and to the point. 5.23e+12. In the year 2010, what is the difference between the Payments (BoP, current US$) in Bhutan and Payments (BoP, current US$) in New Zealand?
Offer a terse response. -4.99e+1. In the year 2011, what is the difference between the Payments (BoP, current US$) of Euro area and Payments (BoP, current US$) of Middle income?
Give a very brief answer. 4.78e+11. In the year 2011, what is the difference between the Payments (BoP, current US$) in Euro area and Payments (BoP, current US$) in Bhutan?
Give a very brief answer. 6.96e+12. In the year 2011, what is the difference between the Payments (BoP, current US$) in Euro area and Payments (BoP, current US$) in New Zealand?
Your answer should be very brief. 6.90e+12. In the year 2011, what is the difference between the Payments (BoP, current US$) in Middle income and Payments (BoP, current US$) in Bhutan?
Keep it short and to the point. 6.48e+12. In the year 2011, what is the difference between the Payments (BoP, current US$) of Middle income and Payments (BoP, current US$) of New Zealand?
Keep it short and to the point. 6.42e+12. In the year 2011, what is the difference between the Payments (BoP, current US$) in Bhutan and Payments (BoP, current US$) in New Zealand?
Your response must be concise. -5.94e+1. In the year 2012, what is the difference between the Payments (BoP, current US$) of Euro area and Payments (BoP, current US$) of Middle income?
Your answer should be very brief. -3.36e+11. In the year 2012, what is the difference between the Payments (BoP, current US$) of Euro area and Payments (BoP, current US$) of Bhutan?
Ensure brevity in your answer.  6.50e+12. In the year 2012, what is the difference between the Payments (BoP, current US$) of Euro area and Payments (BoP, current US$) of New Zealand?
Make the answer very short. 6.44e+12. In the year 2012, what is the difference between the Payments (BoP, current US$) of Middle income and Payments (BoP, current US$) of Bhutan?
Provide a short and direct response. 6.83e+12. In the year 2012, what is the difference between the Payments (BoP, current US$) of Middle income and Payments (BoP, current US$) of New Zealand?
Provide a short and direct response. 6.77e+12. In the year 2012, what is the difference between the Payments (BoP, current US$) in Bhutan and Payments (BoP, current US$) in New Zealand?
Give a very brief answer. -6.14e+1. In the year 2013, what is the difference between the Payments (BoP, current US$) of Euro area and Payments (BoP, current US$) of Middle income?
Provide a short and direct response. -4.88e+11. In the year 2013, what is the difference between the Payments (BoP, current US$) in Euro area and Payments (BoP, current US$) in Bhutan?
Make the answer very short. 6.69e+12. In the year 2013, what is the difference between the Payments (BoP, current US$) of Euro area and Payments (BoP, current US$) of New Zealand?
Ensure brevity in your answer.  6.63e+12. In the year 2013, what is the difference between the Payments (BoP, current US$) in Middle income and Payments (BoP, current US$) in Bhutan?
Make the answer very short. 7.18e+12. In the year 2013, what is the difference between the Payments (BoP, current US$) of Middle income and Payments (BoP, current US$) of New Zealand?
Your answer should be very brief. 7.12e+12. In the year 2013, what is the difference between the Payments (BoP, current US$) in Bhutan and Payments (BoP, current US$) in New Zealand?
Your response must be concise. -6.32e+1. What is the ratio of the Payments (BoP, current US$) in Euro area in 2006 to that in 2007?
Ensure brevity in your answer.  0.82. What is the ratio of the Payments (BoP, current US$) in Middle income in 2006 to that in 2007?
Make the answer very short. 0.82. What is the ratio of the Payments (BoP, current US$) in Bhutan in 2006 to that in 2007?
Give a very brief answer. 0.86. What is the ratio of the Payments (BoP, current US$) of New Zealand in 2006 to that in 2007?
Make the answer very short. 0.83. What is the ratio of the Payments (BoP, current US$) of Euro area in 2006 to that in 2008?
Keep it short and to the point. 0.74. What is the ratio of the Payments (BoP, current US$) in Middle income in 2006 to that in 2008?
Make the answer very short. 0.67. What is the ratio of the Payments (BoP, current US$) of Bhutan in 2006 to that in 2008?
Keep it short and to the point. 0.63. What is the ratio of the Payments (BoP, current US$) of New Zealand in 2006 to that in 2008?
Your answer should be very brief. 0.76. What is the ratio of the Payments (BoP, current US$) in Euro area in 2006 to that in 2009?
Offer a terse response. 0.96. What is the ratio of the Payments (BoP, current US$) of Middle income in 2006 to that in 2009?
Offer a terse response. 0.8. What is the ratio of the Payments (BoP, current US$) of Bhutan in 2006 to that in 2009?
Make the answer very short. 0.71. What is the ratio of the Payments (BoP, current US$) in New Zealand in 2006 to that in 2009?
Give a very brief answer. 1.06. What is the ratio of the Payments (BoP, current US$) of Euro area in 2006 to that in 2010?
Your response must be concise. 0.89. What is the ratio of the Payments (BoP, current US$) of Middle income in 2006 to that in 2010?
Provide a succinct answer. 0.62. What is the ratio of the Payments (BoP, current US$) of Bhutan in 2006 to that in 2010?
Offer a very short reply. 0.51. What is the ratio of the Payments (BoP, current US$) in New Zealand in 2006 to that in 2010?
Give a very brief answer. 0.87. What is the ratio of the Payments (BoP, current US$) in Euro area in 2006 to that in 2011?
Provide a short and direct response. 0.77. What is the ratio of the Payments (BoP, current US$) in Middle income in 2006 to that in 2011?
Offer a terse response. 0.51. What is the ratio of the Payments (BoP, current US$) of Bhutan in 2006 to that in 2011?
Offer a terse response. 0.37. What is the ratio of the Payments (BoP, current US$) of New Zealand in 2006 to that in 2011?
Give a very brief answer. 0.73. What is the ratio of the Payments (BoP, current US$) of Euro area in 2006 to that in 2012?
Ensure brevity in your answer.  0.82. What is the ratio of the Payments (BoP, current US$) of Middle income in 2006 to that in 2012?
Provide a short and direct response. 0.48. What is the ratio of the Payments (BoP, current US$) in Bhutan in 2006 to that in 2012?
Make the answer very short. 0.39. What is the ratio of the Payments (BoP, current US$) of New Zealand in 2006 to that in 2012?
Ensure brevity in your answer.  0.71. What is the ratio of the Payments (BoP, current US$) of Euro area in 2006 to that in 2013?
Ensure brevity in your answer.  0.8. What is the ratio of the Payments (BoP, current US$) in Middle income in 2006 to that in 2013?
Make the answer very short. 0.46. What is the ratio of the Payments (BoP, current US$) in Bhutan in 2006 to that in 2013?
Provide a short and direct response. 0.4. What is the ratio of the Payments (BoP, current US$) of New Zealand in 2006 to that in 2013?
Provide a succinct answer. 0.69. What is the ratio of the Payments (BoP, current US$) in Euro area in 2007 to that in 2008?
Offer a very short reply. 0.9. What is the ratio of the Payments (BoP, current US$) of Middle income in 2007 to that in 2008?
Offer a very short reply. 0.82. What is the ratio of the Payments (BoP, current US$) of Bhutan in 2007 to that in 2008?
Your answer should be very brief. 0.73. What is the ratio of the Payments (BoP, current US$) of New Zealand in 2007 to that in 2008?
Provide a short and direct response. 0.92. What is the ratio of the Payments (BoP, current US$) in Euro area in 2007 to that in 2009?
Provide a short and direct response. 1.17. What is the ratio of the Payments (BoP, current US$) in Bhutan in 2007 to that in 2009?
Give a very brief answer. 0.83. What is the ratio of the Payments (BoP, current US$) of New Zealand in 2007 to that in 2009?
Provide a short and direct response. 1.28. What is the ratio of the Payments (BoP, current US$) in Euro area in 2007 to that in 2010?
Keep it short and to the point. 1.09. What is the ratio of the Payments (BoP, current US$) in Middle income in 2007 to that in 2010?
Make the answer very short. 0.76. What is the ratio of the Payments (BoP, current US$) of Bhutan in 2007 to that in 2010?
Keep it short and to the point. 0.6. What is the ratio of the Payments (BoP, current US$) of New Zealand in 2007 to that in 2010?
Give a very brief answer. 1.06. What is the ratio of the Payments (BoP, current US$) of Euro area in 2007 to that in 2011?
Your answer should be compact. 0.94. What is the ratio of the Payments (BoP, current US$) in Middle income in 2007 to that in 2011?
Your answer should be compact. 0.62. What is the ratio of the Payments (BoP, current US$) in Bhutan in 2007 to that in 2011?
Make the answer very short. 0.43. What is the ratio of the Payments (BoP, current US$) of New Zealand in 2007 to that in 2011?
Your answer should be compact. 0.88. What is the ratio of the Payments (BoP, current US$) in Euro area in 2007 to that in 2012?
Provide a short and direct response. 1.01. What is the ratio of the Payments (BoP, current US$) in Middle income in 2007 to that in 2012?
Ensure brevity in your answer.  0.59. What is the ratio of the Payments (BoP, current US$) of Bhutan in 2007 to that in 2012?
Make the answer very short. 0.46. What is the ratio of the Payments (BoP, current US$) of New Zealand in 2007 to that in 2012?
Provide a short and direct response. 0.86. What is the ratio of the Payments (BoP, current US$) in Euro area in 2007 to that in 2013?
Offer a very short reply. 0.98. What is the ratio of the Payments (BoP, current US$) of Middle income in 2007 to that in 2013?
Offer a terse response. 0.56. What is the ratio of the Payments (BoP, current US$) in Bhutan in 2007 to that in 2013?
Provide a short and direct response. 0.47. What is the ratio of the Payments (BoP, current US$) of New Zealand in 2007 to that in 2013?
Give a very brief answer. 0.83. What is the ratio of the Payments (BoP, current US$) in Euro area in 2008 to that in 2009?
Provide a succinct answer. 1.3. What is the ratio of the Payments (BoP, current US$) in Middle income in 2008 to that in 2009?
Your answer should be very brief. 1.19. What is the ratio of the Payments (BoP, current US$) in Bhutan in 2008 to that in 2009?
Ensure brevity in your answer.  1.14. What is the ratio of the Payments (BoP, current US$) of New Zealand in 2008 to that in 2009?
Provide a succinct answer. 1.39. What is the ratio of the Payments (BoP, current US$) in Euro area in 2008 to that in 2010?
Give a very brief answer. 1.2. What is the ratio of the Payments (BoP, current US$) of Middle income in 2008 to that in 2010?
Make the answer very short. 0.93. What is the ratio of the Payments (BoP, current US$) in Bhutan in 2008 to that in 2010?
Your response must be concise. 0.82. What is the ratio of the Payments (BoP, current US$) of New Zealand in 2008 to that in 2010?
Your answer should be very brief. 1.15. What is the ratio of the Payments (BoP, current US$) of Euro area in 2008 to that in 2011?
Make the answer very short. 1.04. What is the ratio of the Payments (BoP, current US$) in Middle income in 2008 to that in 2011?
Ensure brevity in your answer.  0.76. What is the ratio of the Payments (BoP, current US$) of Bhutan in 2008 to that in 2011?
Your response must be concise. 0.59. What is the ratio of the Payments (BoP, current US$) of New Zealand in 2008 to that in 2011?
Provide a short and direct response. 0.96. What is the ratio of the Payments (BoP, current US$) of Euro area in 2008 to that in 2012?
Offer a very short reply. 1.11. What is the ratio of the Payments (BoP, current US$) in Middle income in 2008 to that in 2012?
Make the answer very short. 0.72. What is the ratio of the Payments (BoP, current US$) of Bhutan in 2008 to that in 2012?
Offer a very short reply. 0.62. What is the ratio of the Payments (BoP, current US$) in New Zealand in 2008 to that in 2012?
Offer a terse response. 0.93. What is the ratio of the Payments (BoP, current US$) in Euro area in 2008 to that in 2013?
Make the answer very short. 1.08. What is the ratio of the Payments (BoP, current US$) of Middle income in 2008 to that in 2013?
Your answer should be compact. 0.68. What is the ratio of the Payments (BoP, current US$) in Bhutan in 2008 to that in 2013?
Offer a terse response. 0.63. What is the ratio of the Payments (BoP, current US$) of New Zealand in 2008 to that in 2013?
Your response must be concise. 0.9. What is the ratio of the Payments (BoP, current US$) in Euro area in 2009 to that in 2010?
Your response must be concise. 0.92. What is the ratio of the Payments (BoP, current US$) of Middle income in 2009 to that in 2010?
Keep it short and to the point. 0.78. What is the ratio of the Payments (BoP, current US$) in Bhutan in 2009 to that in 2010?
Your response must be concise. 0.72. What is the ratio of the Payments (BoP, current US$) in New Zealand in 2009 to that in 2010?
Offer a terse response. 0.82. What is the ratio of the Payments (BoP, current US$) of Euro area in 2009 to that in 2011?
Keep it short and to the point. 0.8. What is the ratio of the Payments (BoP, current US$) of Middle income in 2009 to that in 2011?
Your response must be concise. 0.64. What is the ratio of the Payments (BoP, current US$) of Bhutan in 2009 to that in 2011?
Your response must be concise. 0.52. What is the ratio of the Payments (BoP, current US$) in New Zealand in 2009 to that in 2011?
Offer a terse response. 0.69. What is the ratio of the Payments (BoP, current US$) in Euro area in 2009 to that in 2012?
Offer a very short reply. 0.86. What is the ratio of the Payments (BoP, current US$) of Middle income in 2009 to that in 2012?
Offer a very short reply. 0.6. What is the ratio of the Payments (BoP, current US$) of Bhutan in 2009 to that in 2012?
Give a very brief answer. 0.55. What is the ratio of the Payments (BoP, current US$) of New Zealand in 2009 to that in 2012?
Your response must be concise. 0.67. What is the ratio of the Payments (BoP, current US$) in Euro area in 2009 to that in 2013?
Provide a short and direct response. 0.83. What is the ratio of the Payments (BoP, current US$) of Middle income in 2009 to that in 2013?
Your response must be concise. 0.57. What is the ratio of the Payments (BoP, current US$) of Bhutan in 2009 to that in 2013?
Offer a terse response. 0.56. What is the ratio of the Payments (BoP, current US$) in New Zealand in 2009 to that in 2013?
Your answer should be very brief. 0.65. What is the ratio of the Payments (BoP, current US$) in Euro area in 2010 to that in 2011?
Your answer should be compact. 0.86. What is the ratio of the Payments (BoP, current US$) in Middle income in 2010 to that in 2011?
Provide a succinct answer. 0.81. What is the ratio of the Payments (BoP, current US$) of Bhutan in 2010 to that in 2011?
Offer a very short reply. 0.72. What is the ratio of the Payments (BoP, current US$) in New Zealand in 2010 to that in 2011?
Provide a succinct answer. 0.84. What is the ratio of the Payments (BoP, current US$) of Euro area in 2010 to that in 2012?
Make the answer very short. 0.93. What is the ratio of the Payments (BoP, current US$) in Middle income in 2010 to that in 2012?
Keep it short and to the point. 0.77. What is the ratio of the Payments (BoP, current US$) of Bhutan in 2010 to that in 2012?
Offer a terse response. 0.76. What is the ratio of the Payments (BoP, current US$) of New Zealand in 2010 to that in 2012?
Keep it short and to the point. 0.81. What is the ratio of the Payments (BoP, current US$) of Euro area in 2010 to that in 2013?
Your response must be concise. 0.9. What is the ratio of the Payments (BoP, current US$) of Middle income in 2010 to that in 2013?
Your answer should be very brief. 0.74. What is the ratio of the Payments (BoP, current US$) in Bhutan in 2010 to that in 2013?
Offer a very short reply. 0.78. What is the ratio of the Payments (BoP, current US$) in New Zealand in 2010 to that in 2013?
Your answer should be compact. 0.79. What is the ratio of the Payments (BoP, current US$) of Euro area in 2011 to that in 2012?
Offer a very short reply. 1.07. What is the ratio of the Payments (BoP, current US$) of Middle income in 2011 to that in 2012?
Your answer should be compact. 0.95. What is the ratio of the Payments (BoP, current US$) of Bhutan in 2011 to that in 2012?
Provide a short and direct response. 1.06. What is the ratio of the Payments (BoP, current US$) of New Zealand in 2011 to that in 2012?
Provide a short and direct response. 0.97. What is the ratio of the Payments (BoP, current US$) in Euro area in 2011 to that in 2013?
Your answer should be compact. 1.04. What is the ratio of the Payments (BoP, current US$) of Middle income in 2011 to that in 2013?
Make the answer very short. 0.9. What is the ratio of the Payments (BoP, current US$) in Bhutan in 2011 to that in 2013?
Keep it short and to the point. 1.08. What is the ratio of the Payments (BoP, current US$) in New Zealand in 2011 to that in 2013?
Ensure brevity in your answer.  0.94. What is the ratio of the Payments (BoP, current US$) of Euro area in 2012 to that in 2013?
Your answer should be compact. 0.97. What is the ratio of the Payments (BoP, current US$) in Middle income in 2012 to that in 2013?
Offer a terse response. 0.95. What is the ratio of the Payments (BoP, current US$) of Bhutan in 2012 to that in 2013?
Your answer should be very brief. 1.02. What is the ratio of the Payments (BoP, current US$) in New Zealand in 2012 to that in 2013?
Give a very brief answer. 0.97. What is the difference between the highest and the second highest Payments (BoP, current US$) of Euro area?
Your answer should be compact. 2.65e+11. What is the difference between the highest and the second highest Payments (BoP, current US$) in Middle income?
Offer a terse response. 3.49e+11. What is the difference between the highest and the second highest Payments (BoP, current US$) of Bhutan?
Give a very brief answer. 8.20e+07. What is the difference between the highest and the second highest Payments (BoP, current US$) of New Zealand?
Ensure brevity in your answer.  1.75e+09. What is the difference between the highest and the lowest Payments (BoP, current US$) in Euro area?
Keep it short and to the point. 1.88e+12. What is the difference between the highest and the lowest Payments (BoP, current US$) in Middle income?
Provide a succinct answer. 3.90e+12. What is the difference between the highest and the lowest Payments (BoP, current US$) in Bhutan?
Your response must be concise. 9.01e+08. What is the difference between the highest and the lowest Payments (BoP, current US$) of New Zealand?
Offer a terse response. 2.25e+1. 